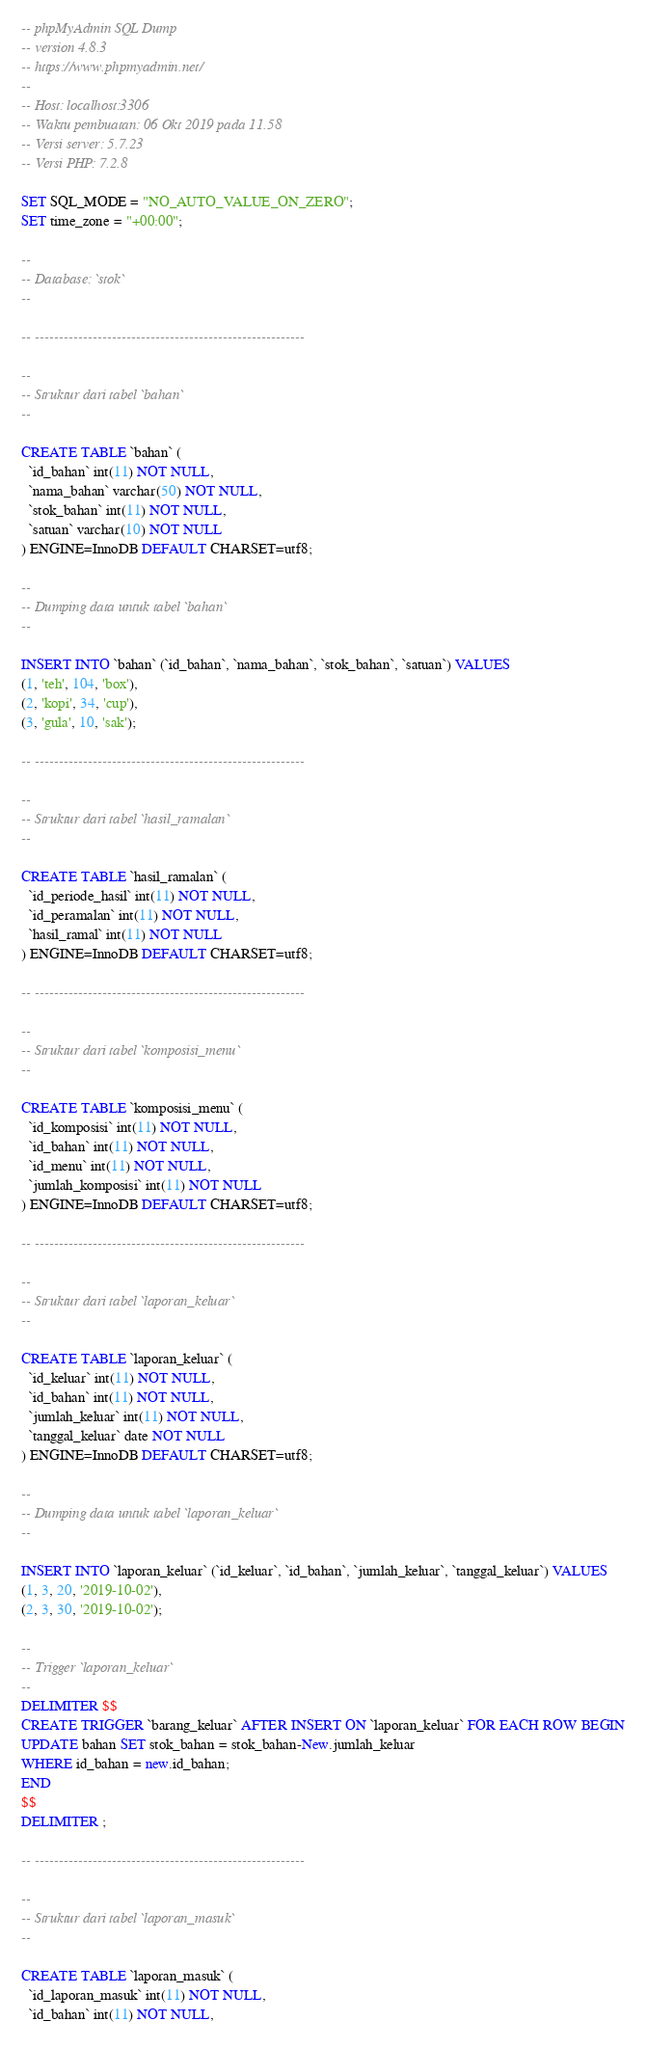<code> <loc_0><loc_0><loc_500><loc_500><_SQL_>-- phpMyAdmin SQL Dump
-- version 4.8.3
-- https://www.phpmyadmin.net/
--
-- Host: localhost:3306
-- Waktu pembuatan: 06 Okt 2019 pada 11.58
-- Versi server: 5.7.23
-- Versi PHP: 7.2.8

SET SQL_MODE = "NO_AUTO_VALUE_ON_ZERO";
SET time_zone = "+00:00";

--
-- Database: `stok`
--

-- --------------------------------------------------------

--
-- Struktur dari tabel `bahan`
--

CREATE TABLE `bahan` (
  `id_bahan` int(11) NOT NULL,
  `nama_bahan` varchar(50) NOT NULL,
  `stok_bahan` int(11) NOT NULL,
  `satuan` varchar(10) NOT NULL
) ENGINE=InnoDB DEFAULT CHARSET=utf8;

--
-- Dumping data untuk tabel `bahan`
--

INSERT INTO `bahan` (`id_bahan`, `nama_bahan`, `stok_bahan`, `satuan`) VALUES
(1, 'teh', 104, 'box'),
(2, 'kopi', 34, 'cup'),
(3, 'gula', 10, 'sak');

-- --------------------------------------------------------

--
-- Struktur dari tabel `hasil_ramalan`
--

CREATE TABLE `hasil_ramalan` (
  `id_periode_hasil` int(11) NOT NULL,
  `id_peramalan` int(11) NOT NULL,
  `hasil_ramal` int(11) NOT NULL
) ENGINE=InnoDB DEFAULT CHARSET=utf8;

-- --------------------------------------------------------

--
-- Struktur dari tabel `komposisi_menu`
--

CREATE TABLE `komposisi_menu` (
  `id_komposisi` int(11) NOT NULL,
  `id_bahan` int(11) NOT NULL,
  `id_menu` int(11) NOT NULL,
  `jumlah_komposisi` int(11) NOT NULL
) ENGINE=InnoDB DEFAULT CHARSET=utf8;

-- --------------------------------------------------------

--
-- Struktur dari tabel `laporan_keluar`
--

CREATE TABLE `laporan_keluar` (
  `id_keluar` int(11) NOT NULL,
  `id_bahan` int(11) NOT NULL,
  `jumlah_keluar` int(11) NOT NULL,
  `tanggal_keluar` date NOT NULL
) ENGINE=InnoDB DEFAULT CHARSET=utf8;

--
-- Dumping data untuk tabel `laporan_keluar`
--

INSERT INTO `laporan_keluar` (`id_keluar`, `id_bahan`, `jumlah_keluar`, `tanggal_keluar`) VALUES
(1, 3, 20, '2019-10-02'),
(2, 3, 30, '2019-10-02');

--
-- Trigger `laporan_keluar`
--
DELIMITER $$
CREATE TRIGGER `barang_keluar` AFTER INSERT ON `laporan_keluar` FOR EACH ROW BEGIN
UPDATE bahan SET stok_bahan = stok_bahan-New.jumlah_keluar
WHERE id_bahan = new.id_bahan;
END
$$
DELIMITER ;

-- --------------------------------------------------------

--
-- Struktur dari tabel `laporan_masuk`
--

CREATE TABLE `laporan_masuk` (
  `id_laporan_masuk` int(11) NOT NULL,
  `id_bahan` int(11) NOT NULL,</code> 